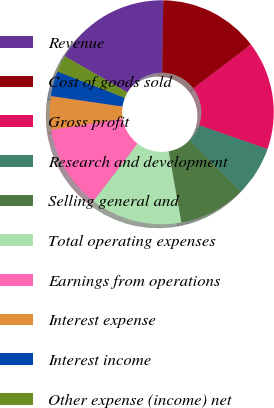Convert chart. <chart><loc_0><loc_0><loc_500><loc_500><pie_chart><fcel>Revenue<fcel>Cost of goods sold<fcel>Gross profit<fcel>Research and development<fcel>Selling general and<fcel>Total operating expenses<fcel>Earnings from operations<fcel>Interest expense<fcel>Interest income<fcel>Other expense (income) net<nl><fcel>16.87%<fcel>14.46%<fcel>15.66%<fcel>7.23%<fcel>9.64%<fcel>13.25%<fcel>12.05%<fcel>4.82%<fcel>3.61%<fcel>2.41%<nl></chart> 